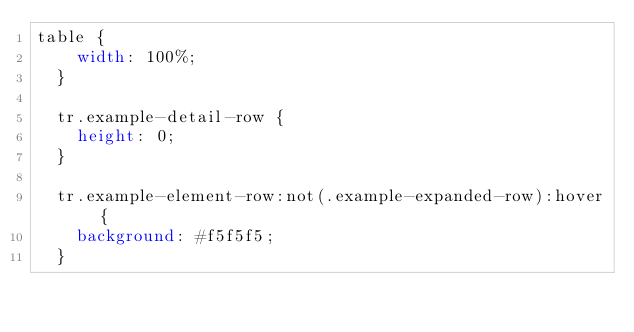Convert code to text. <code><loc_0><loc_0><loc_500><loc_500><_CSS_>table {
    width: 100%;
  }
  
  tr.example-detail-row {
    height: 0;
  }
  
  tr.example-element-row:not(.example-expanded-row):hover {
    background: #f5f5f5;
  }
  </code> 